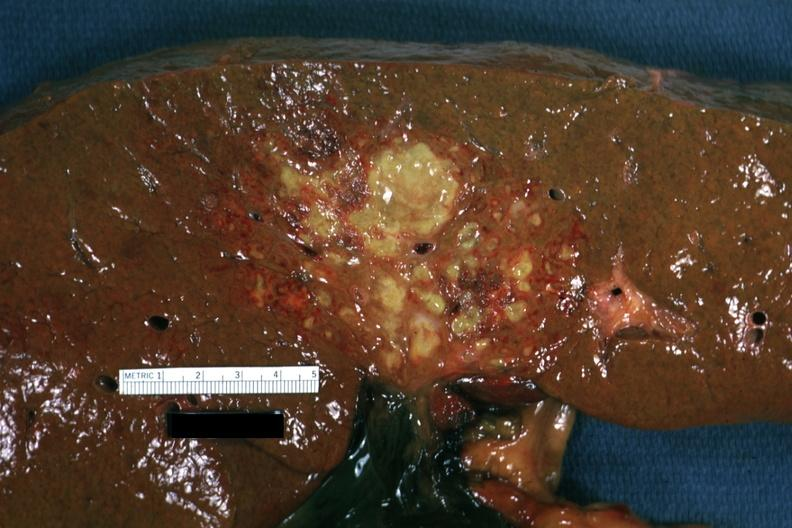what is present?
Answer the question using a single word or phrase. Hepatobiliary 